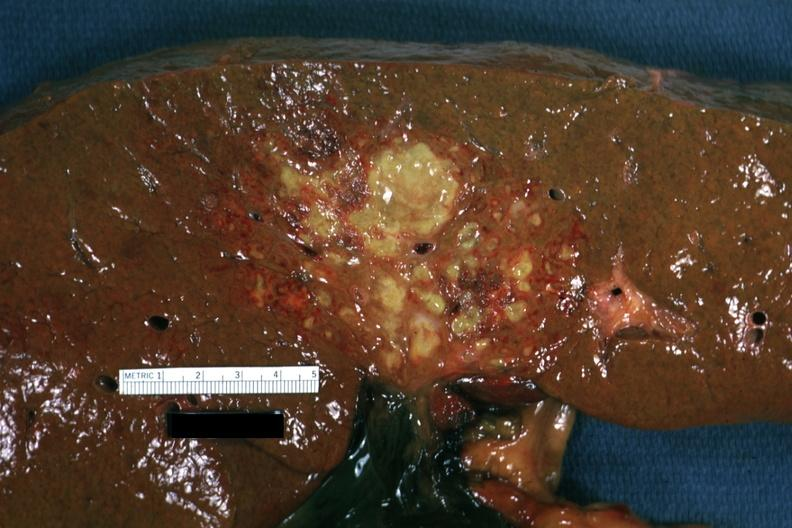what is present?
Answer the question using a single word or phrase. Hepatobiliary 